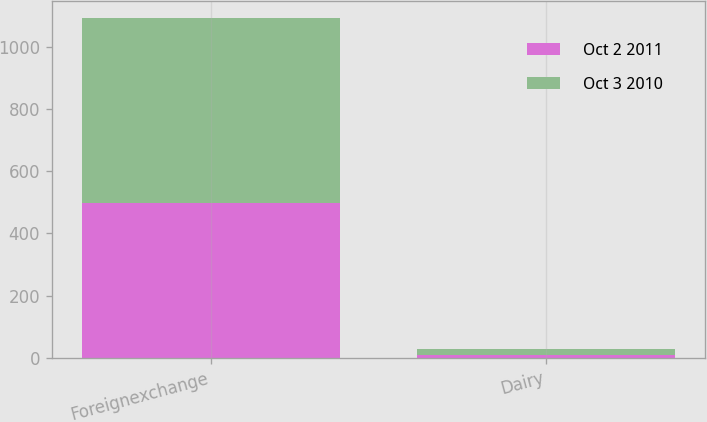Convert chart. <chart><loc_0><loc_0><loc_500><loc_500><stacked_bar_chart><ecel><fcel>Foreignexchange<fcel>Dairy<nl><fcel>Oct 2 2011<fcel>499<fcel>10<nl><fcel>Oct 3 2010<fcel>593<fcel>20<nl></chart> 